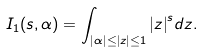<formula> <loc_0><loc_0><loc_500><loc_500>I _ { 1 } ( s , \alpha ) = \int _ { | \alpha | \leq | z | \leq 1 } { | z | } ^ { s } d z .</formula> 